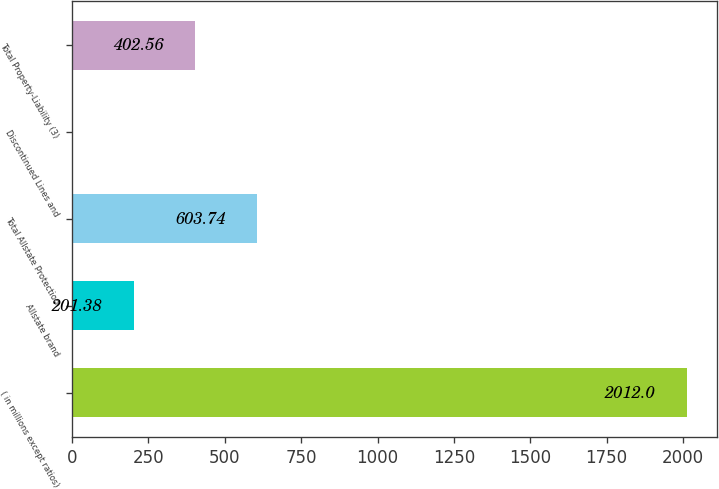Convert chart. <chart><loc_0><loc_0><loc_500><loc_500><bar_chart><fcel>( in millions except ratios)<fcel>Allstate brand<fcel>Total Allstate Protection<fcel>Discontinued Lines and<fcel>Total Property-Liability (3)<nl><fcel>2012<fcel>201.38<fcel>603.74<fcel>0.2<fcel>402.56<nl></chart> 